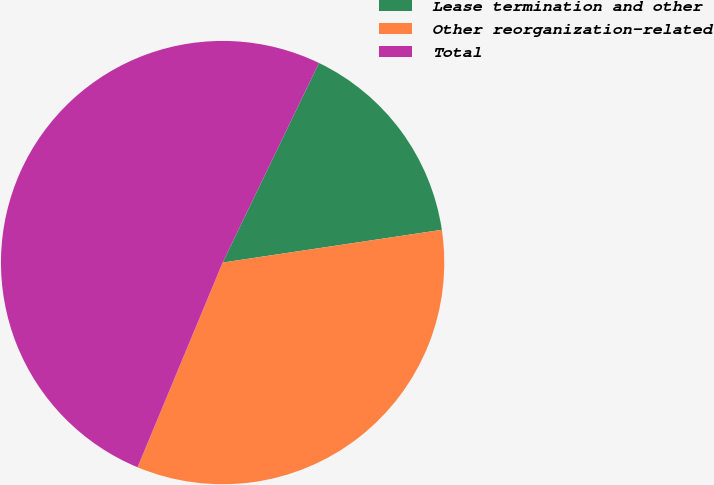<chart> <loc_0><loc_0><loc_500><loc_500><pie_chart><fcel>Lease termination and other<fcel>Other reorganization-related<fcel>Total<nl><fcel>15.48%<fcel>33.63%<fcel>50.89%<nl></chart> 